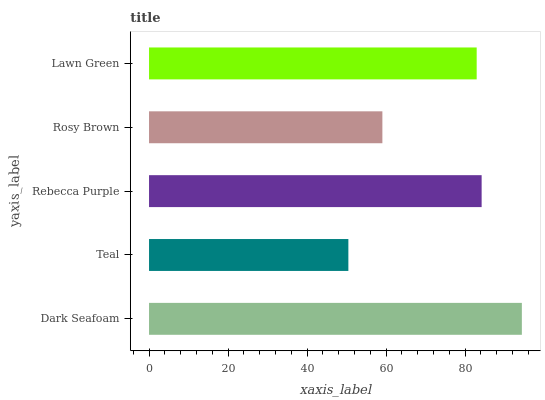Is Teal the minimum?
Answer yes or no. Yes. Is Dark Seafoam the maximum?
Answer yes or no. Yes. Is Rebecca Purple the minimum?
Answer yes or no. No. Is Rebecca Purple the maximum?
Answer yes or no. No. Is Rebecca Purple greater than Teal?
Answer yes or no. Yes. Is Teal less than Rebecca Purple?
Answer yes or no. Yes. Is Teal greater than Rebecca Purple?
Answer yes or no. No. Is Rebecca Purple less than Teal?
Answer yes or no. No. Is Lawn Green the high median?
Answer yes or no. Yes. Is Lawn Green the low median?
Answer yes or no. Yes. Is Rosy Brown the high median?
Answer yes or no. No. Is Teal the low median?
Answer yes or no. No. 